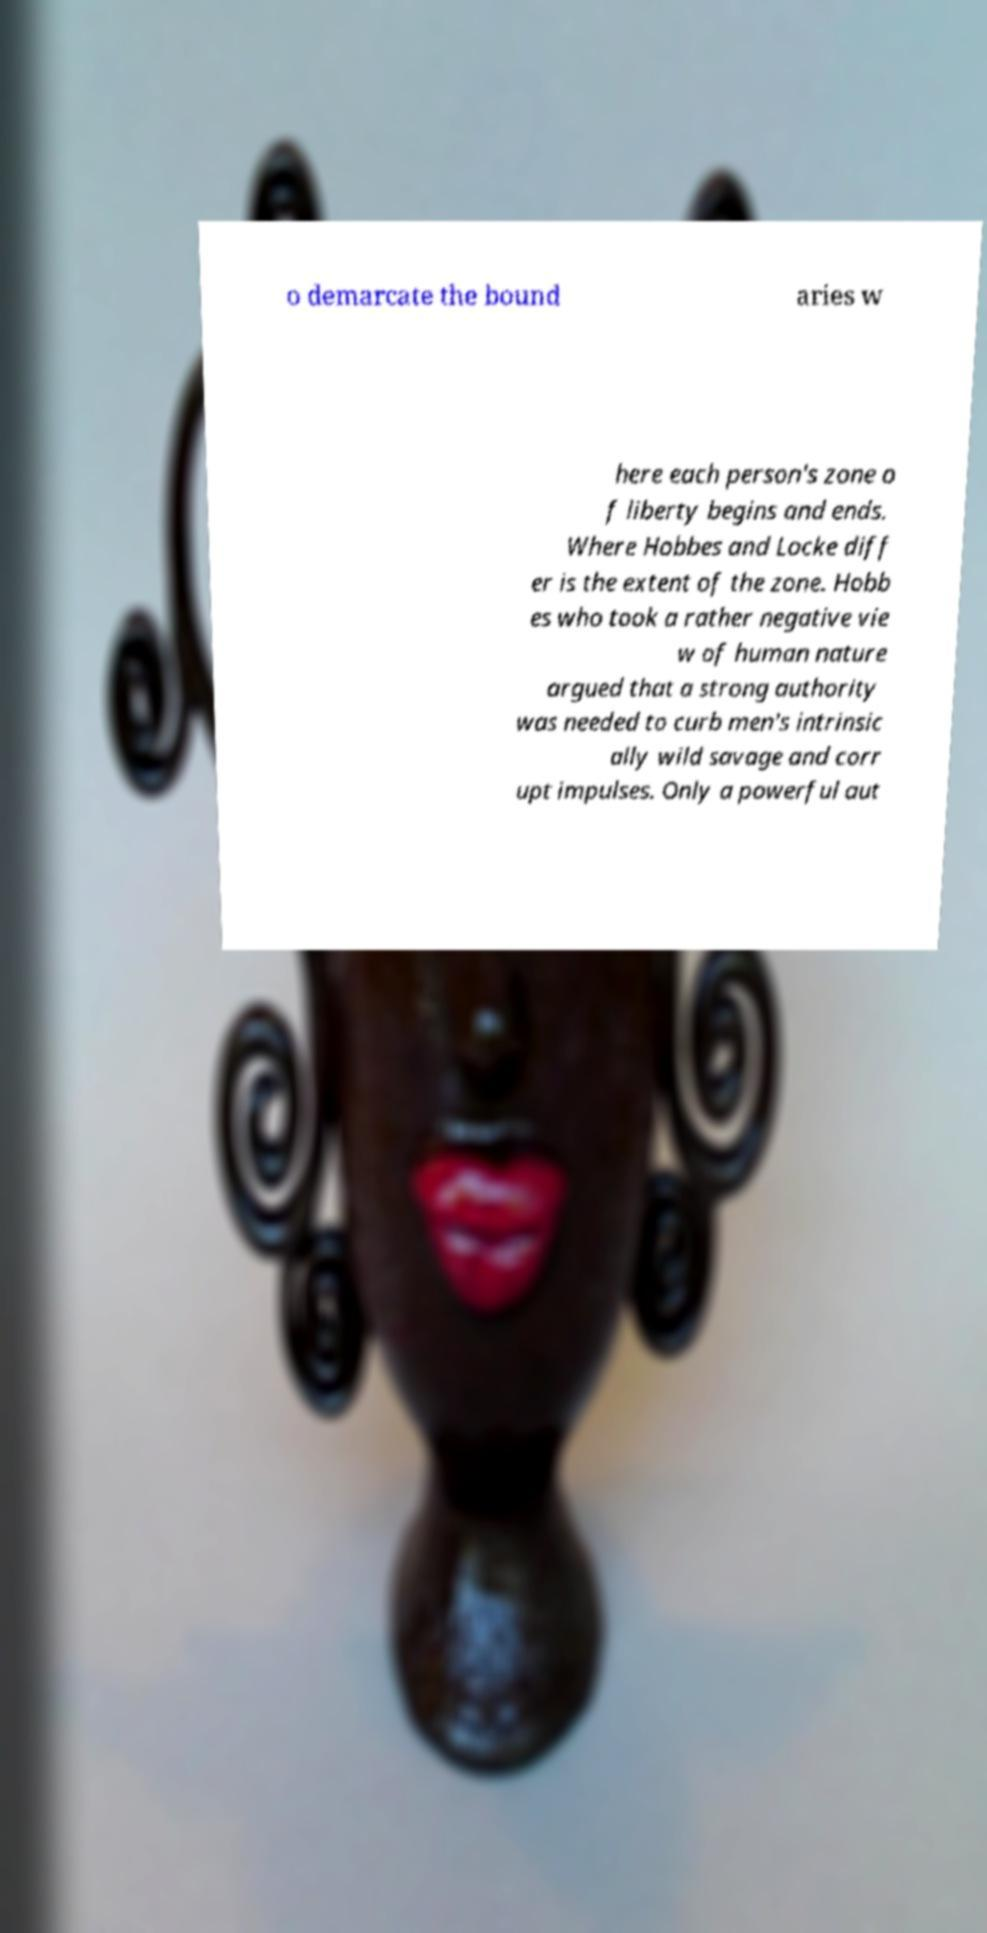Could you extract and type out the text from this image? o demarcate the bound aries w here each person's zone o f liberty begins and ends. Where Hobbes and Locke diff er is the extent of the zone. Hobb es who took a rather negative vie w of human nature argued that a strong authority was needed to curb men's intrinsic ally wild savage and corr upt impulses. Only a powerful aut 